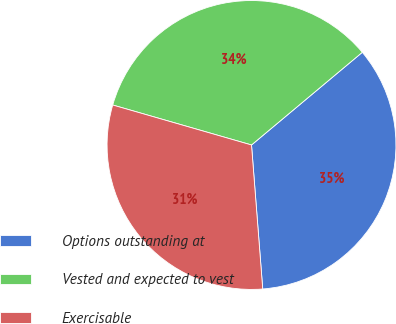<chart> <loc_0><loc_0><loc_500><loc_500><pie_chart><fcel>Options outstanding at<fcel>Vested and expected to vest<fcel>Exercisable<nl><fcel>34.85%<fcel>34.45%<fcel>30.7%<nl></chart> 